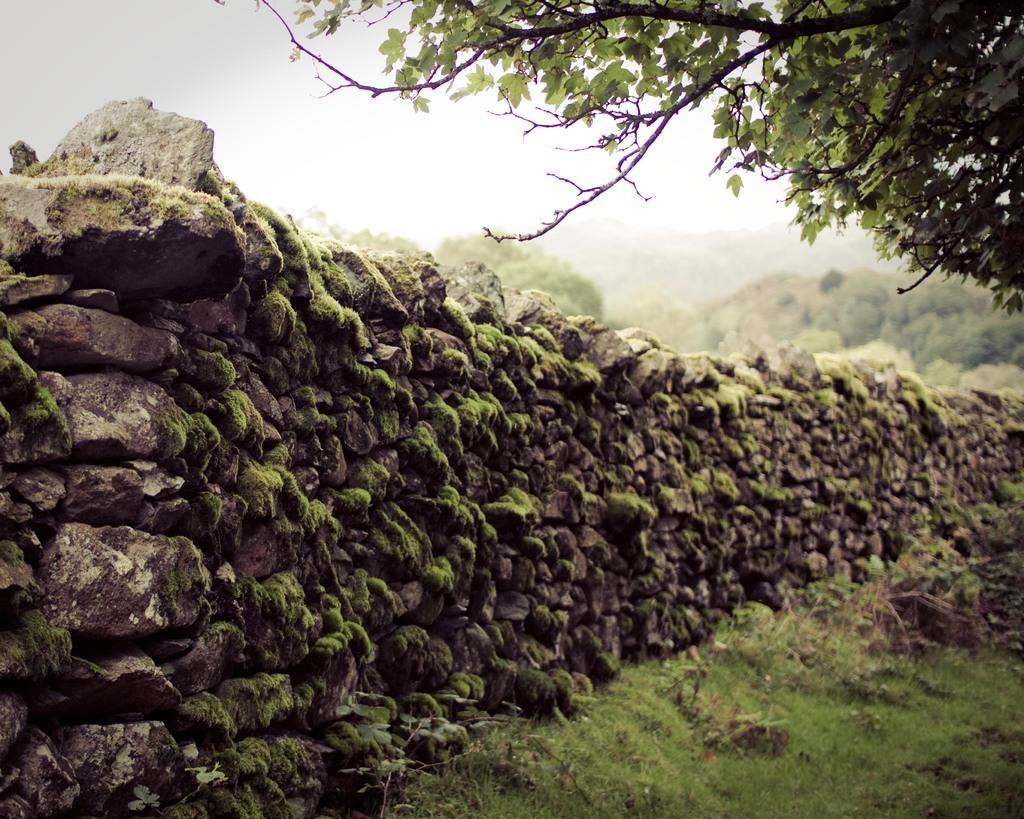Please provide a concise description of this image. In the center of the image we can see the stone wall. In the background of the image we can see the trees. At the bottom of the image we can see the sky. 